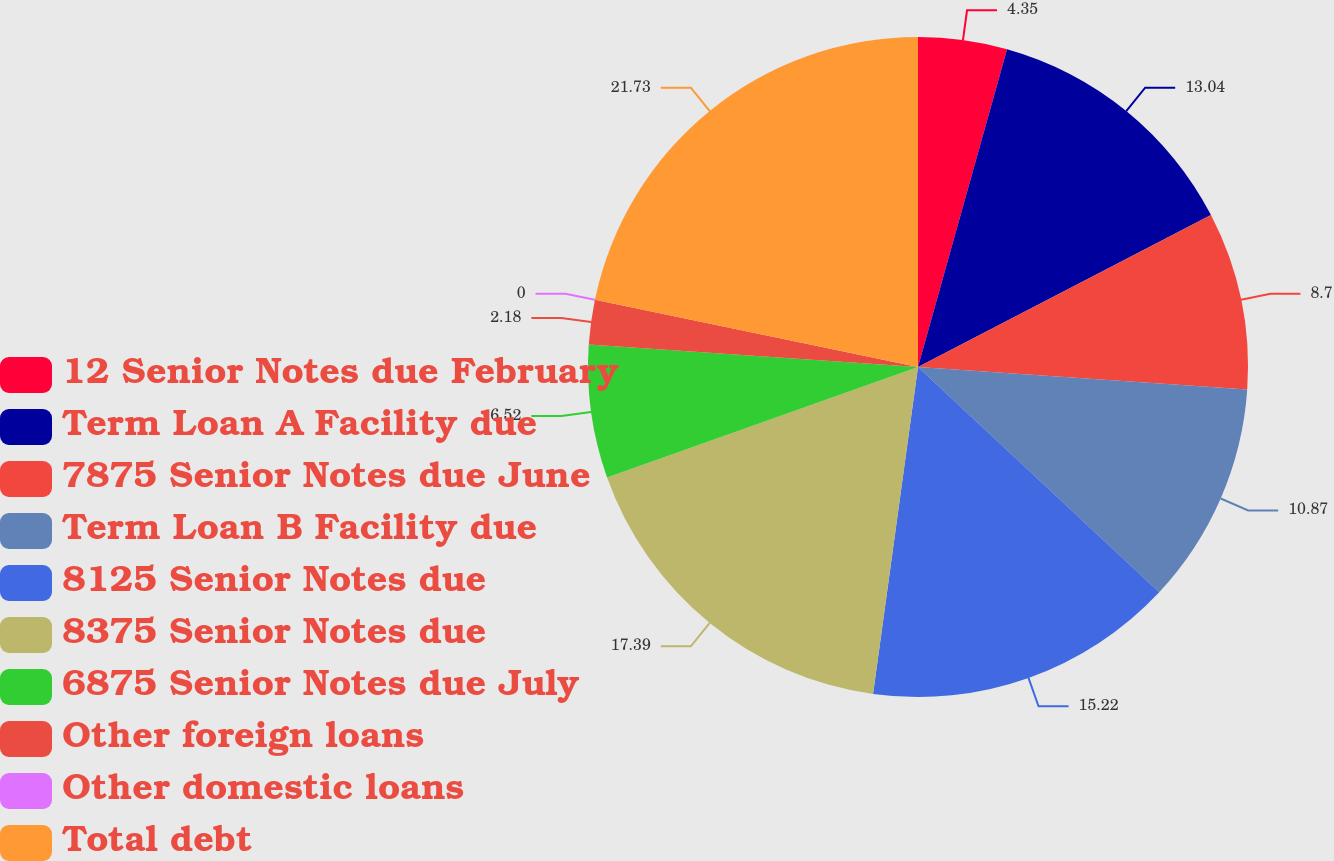Convert chart to OTSL. <chart><loc_0><loc_0><loc_500><loc_500><pie_chart><fcel>12 Senior Notes due February<fcel>Term Loan A Facility due<fcel>7875 Senior Notes due June<fcel>Term Loan B Facility due<fcel>8125 Senior Notes due<fcel>8375 Senior Notes due<fcel>6875 Senior Notes due July<fcel>Other foreign loans<fcel>Other domestic loans<fcel>Total debt<nl><fcel>4.35%<fcel>13.04%<fcel>8.7%<fcel>10.87%<fcel>15.22%<fcel>17.39%<fcel>6.52%<fcel>2.18%<fcel>0.0%<fcel>21.74%<nl></chart> 